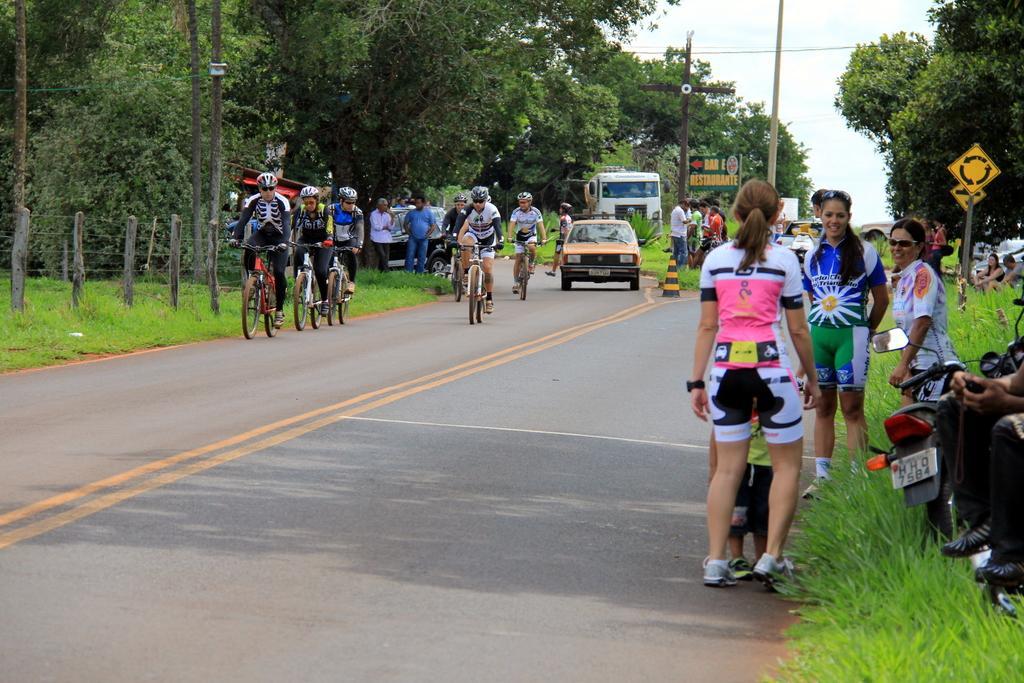Please provide a concise description of this image. This picture is clicked outside the city. On the right side, we see the grass, a bike and the people are standing. Behind them, we see a board in yellow color. We see the trees, cars and the people. At the bottom, we see the road. In the middle, we see the people are riding their bicycles. Behind them, we see the vehicles and the people are standing. Beside them, we see the traffic stopper and a pole and a board in green color with some text written on it. On the left side, we see the grass and the wooden fence. There are trees in the background. At the top, we see the sky. 